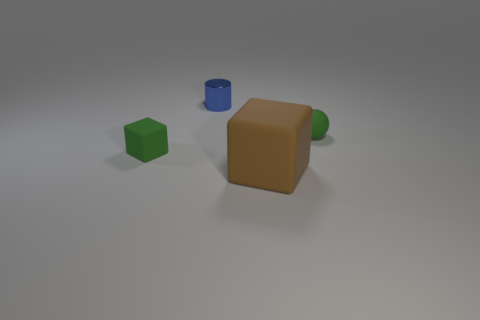What color is the object that is both behind the small green rubber cube and right of the tiny blue metallic cylinder?
Your response must be concise. Green. Are there any green rubber balls that have the same size as the green block?
Your response must be concise. Yes. There is a rubber thing on the right side of the brown block in front of the matte sphere; what is its size?
Make the answer very short. Small. Are there fewer blocks that are behind the tiny green ball than big shiny blocks?
Provide a short and direct response. No. Do the tiny block and the metallic thing have the same color?
Your answer should be compact. No. How big is the green block?
Make the answer very short. Small. What number of other spheres have the same color as the small rubber sphere?
Provide a short and direct response. 0. There is a tiny green rubber thing that is on the right side of the tiny green matte object to the left of the brown matte thing; is there a big brown block on the right side of it?
Offer a terse response. No. The green rubber object that is the same size as the green rubber ball is what shape?
Ensure brevity in your answer.  Cube. How many big things are either matte objects or cubes?
Your response must be concise. 1. 